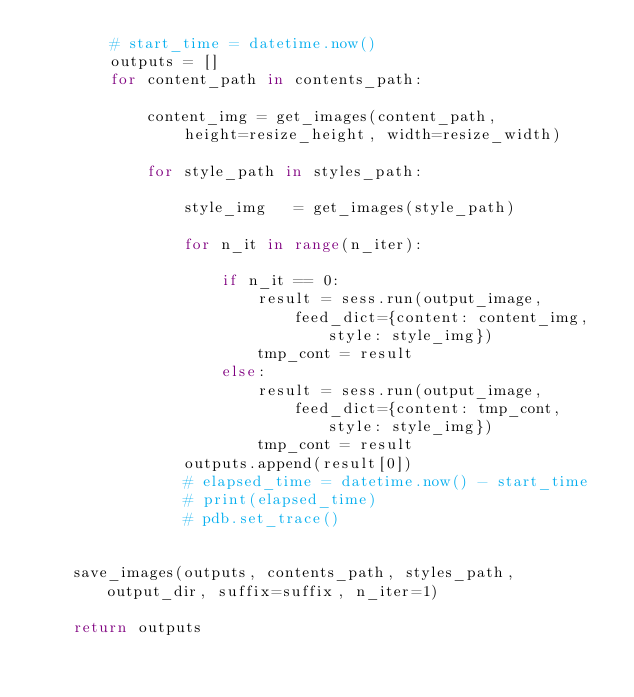<code> <loc_0><loc_0><loc_500><loc_500><_Python_>        # start_time = datetime.now()
        outputs = []
        for content_path in contents_path:

            content_img = get_images(content_path, 
                height=resize_height, width=resize_width)

            for style_path in styles_path:

                style_img   = get_images(style_path)

                for n_it in range(n_iter):
                    
                    if n_it == 0:
                        result = sess.run(output_image, 
                            feed_dict={content: content_img, style: style_img})
                        tmp_cont = result
                    else:
                        result = sess.run(output_image, 
                            feed_dict={content: tmp_cont, style: style_img})
                        tmp_cont = result
                outputs.append(result[0])
                # elapsed_time = datetime.now() - start_time
                # print(elapsed_time)
                # pdb.set_trace()
        
                            
    save_images(outputs, contents_path, styles_path, output_dir, suffix=suffix, n_iter=1)

    return outputs

</code> 